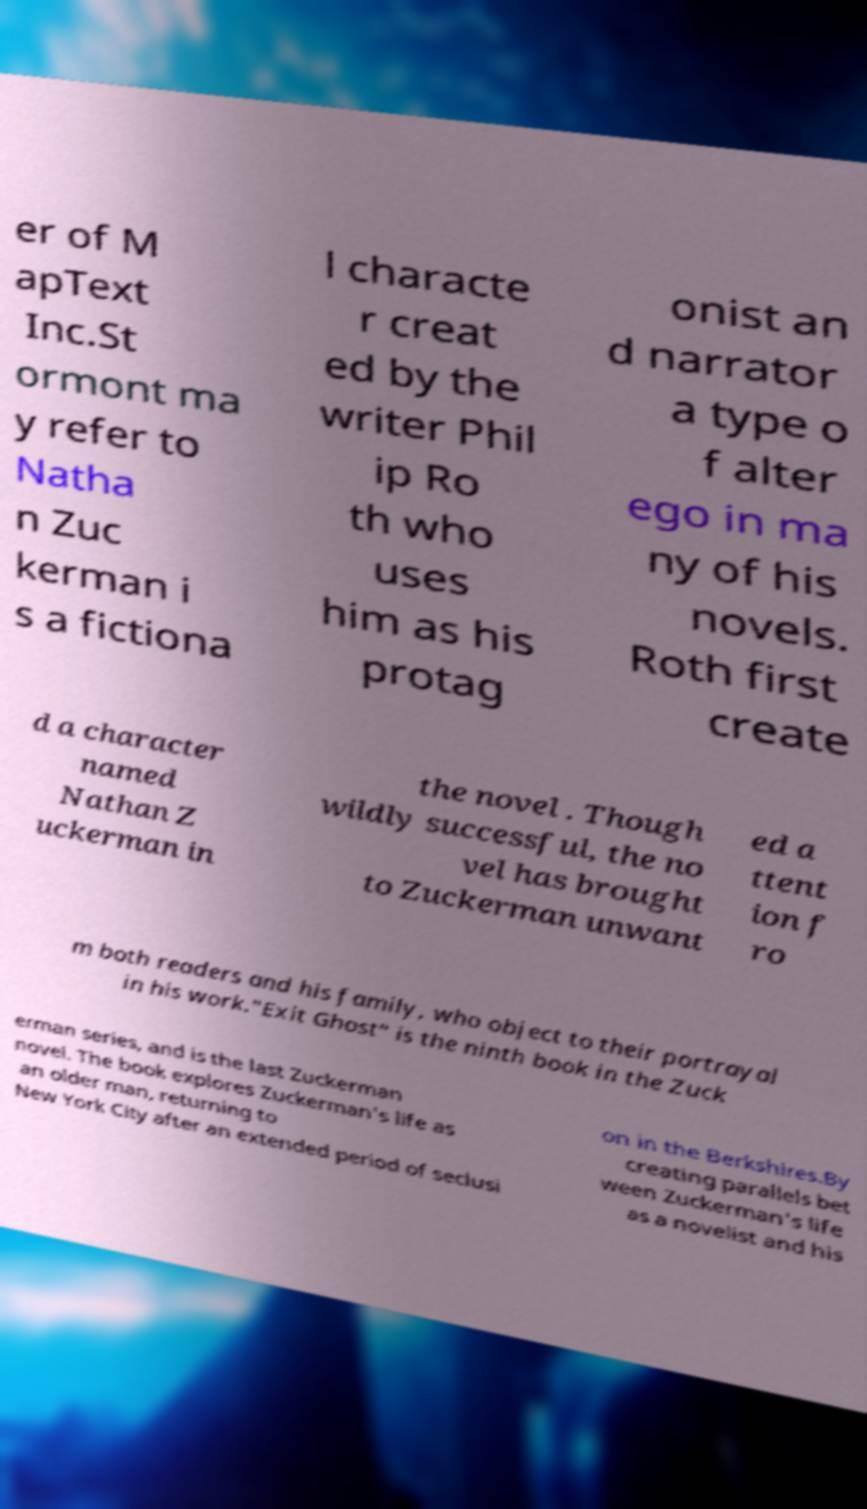For documentation purposes, I need the text within this image transcribed. Could you provide that? er of M apText Inc.St ormont ma y refer to Natha n Zuc kerman i s a fictiona l characte r creat ed by the writer Phil ip Ro th who uses him as his protag onist an d narrator a type o f alter ego in ma ny of his novels. Roth first create d a character named Nathan Z uckerman in the novel . Though wildly successful, the no vel has brought to Zuckerman unwant ed a ttent ion f ro m both readers and his family, who object to their portrayal in his work."Exit Ghost" is the ninth book in the Zuck erman series, and is the last Zuckerman novel. The book explores Zuckerman's life as an older man, returning to New York City after an extended period of seclusi on in the Berkshires.By creating parallels bet ween Zuckerman's life as a novelist and his 